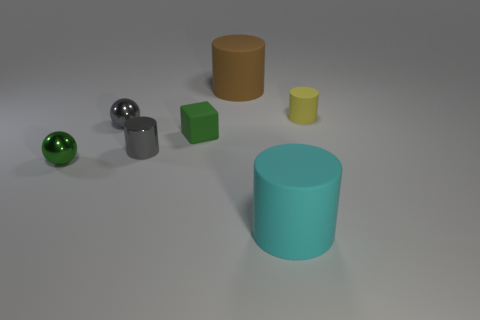Subtract 1 cylinders. How many cylinders are left? 3 Subtract all red cylinders. Subtract all purple cubes. How many cylinders are left? 4 Add 3 big matte cylinders. How many objects exist? 10 Subtract all balls. How many objects are left? 5 Subtract 1 gray cylinders. How many objects are left? 6 Subtract all spheres. Subtract all matte objects. How many objects are left? 1 Add 7 green metal objects. How many green metal objects are left? 8 Add 6 tiny yellow matte objects. How many tiny yellow matte objects exist? 7 